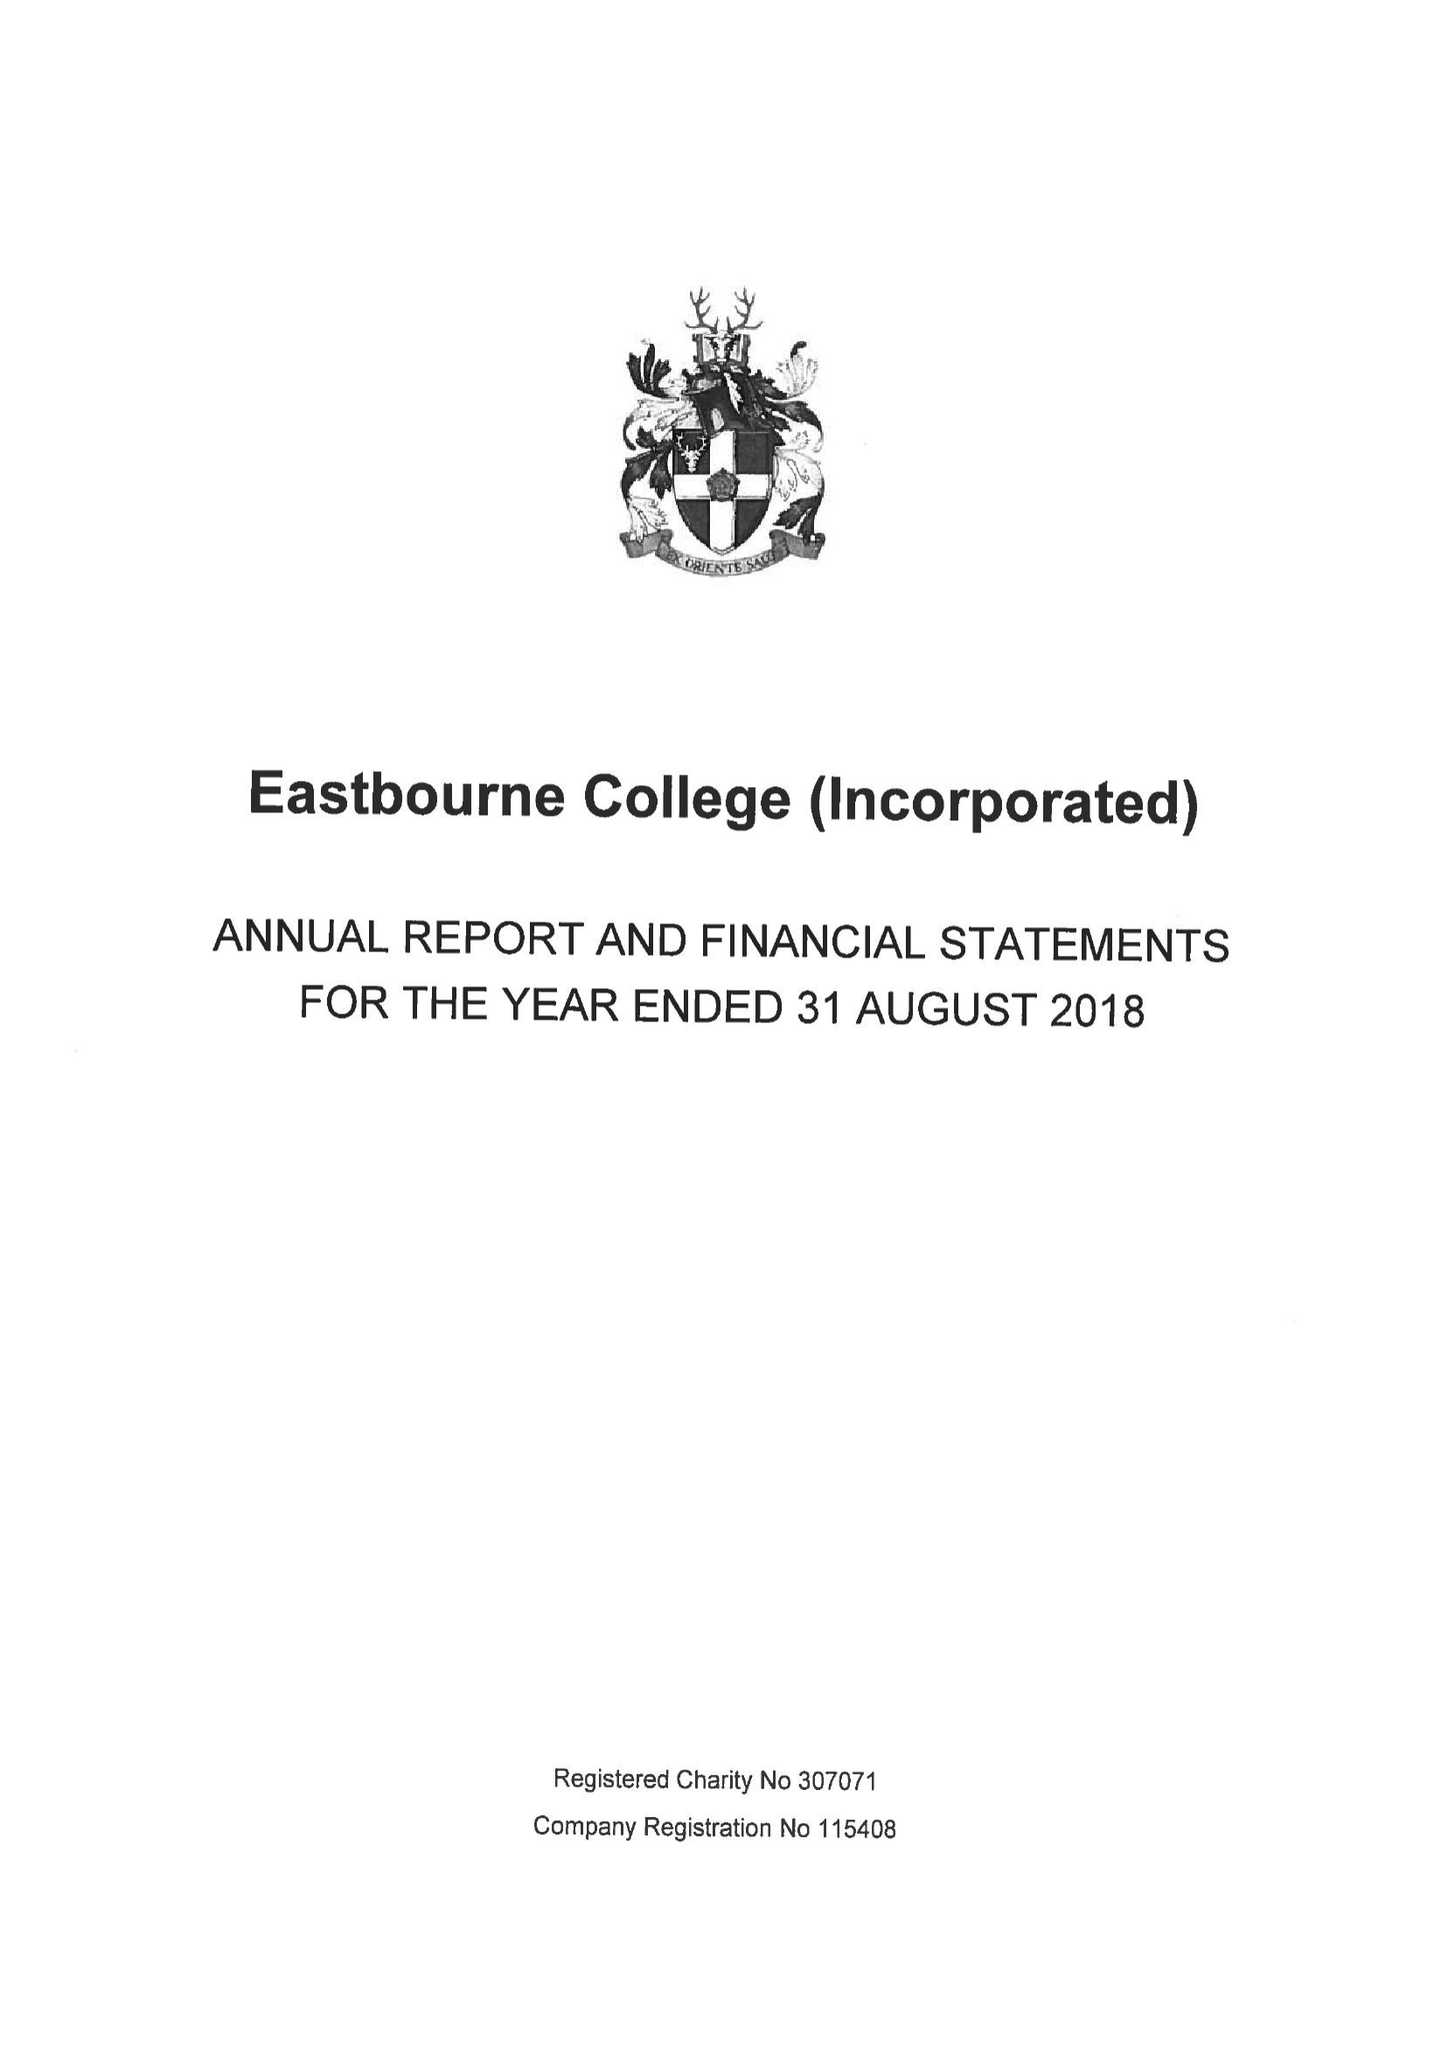What is the value for the address__street_line?
Answer the question using a single word or phrase. OLD WISH ROAD 